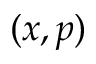Convert formula to latex. <formula><loc_0><loc_0><loc_500><loc_500>( x , p )</formula> 